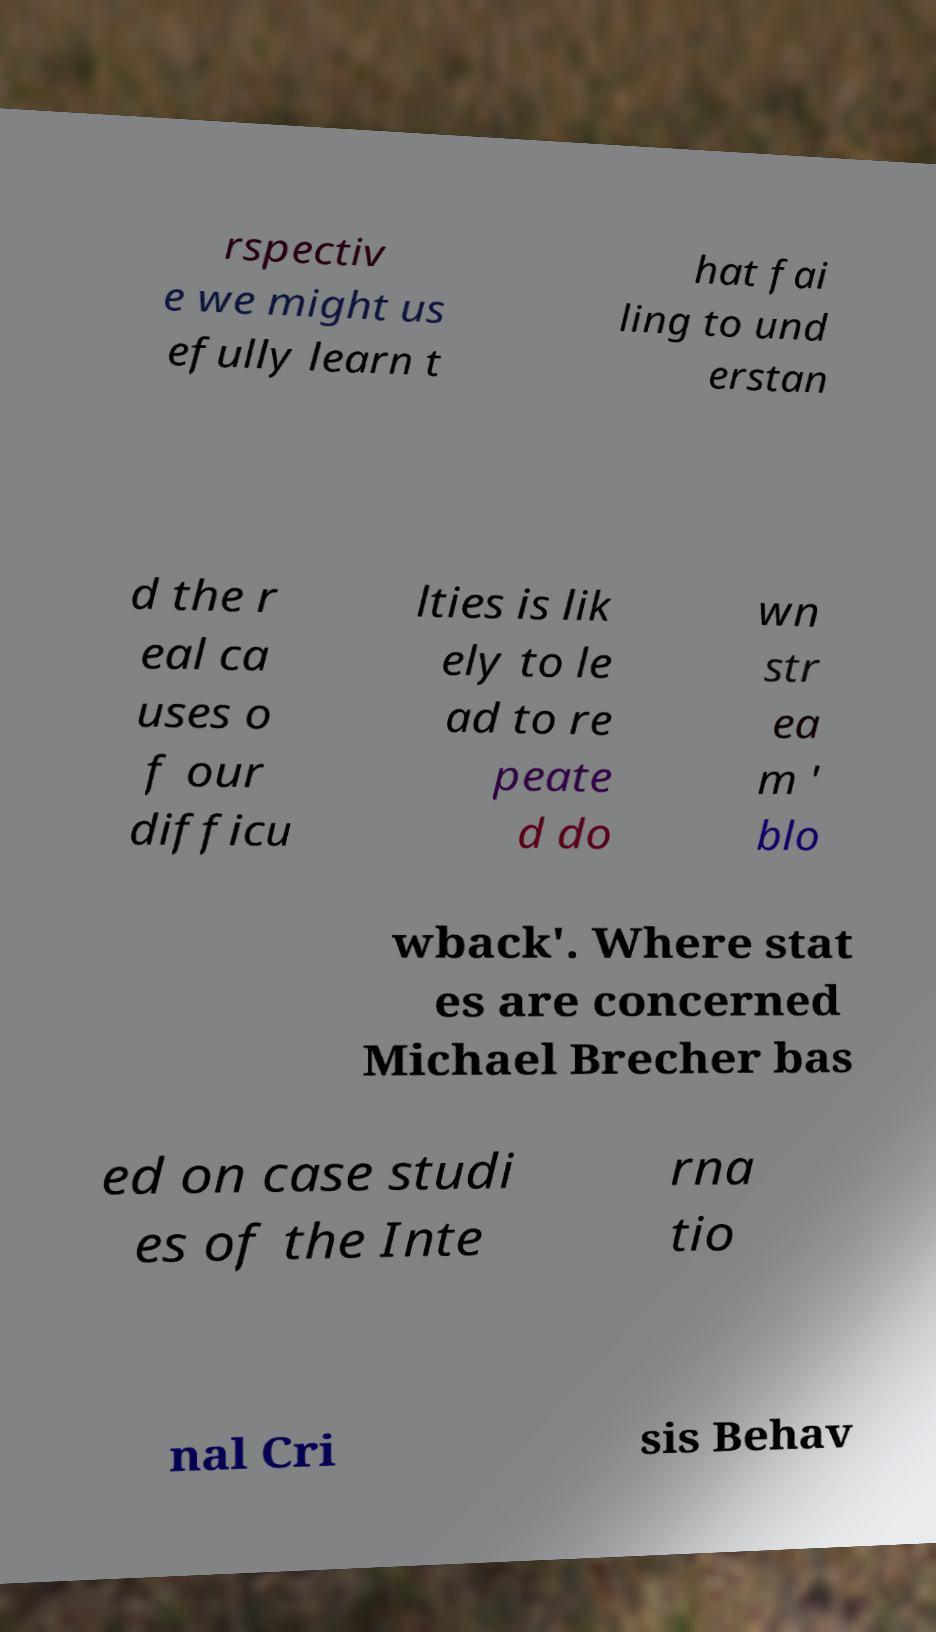There's text embedded in this image that I need extracted. Can you transcribe it verbatim? rspectiv e we might us efully learn t hat fai ling to und erstan d the r eal ca uses o f our difficu lties is lik ely to le ad to re peate d do wn str ea m ' blo wback'. Where stat es are concerned Michael Brecher bas ed on case studi es of the Inte rna tio nal Cri sis Behav 